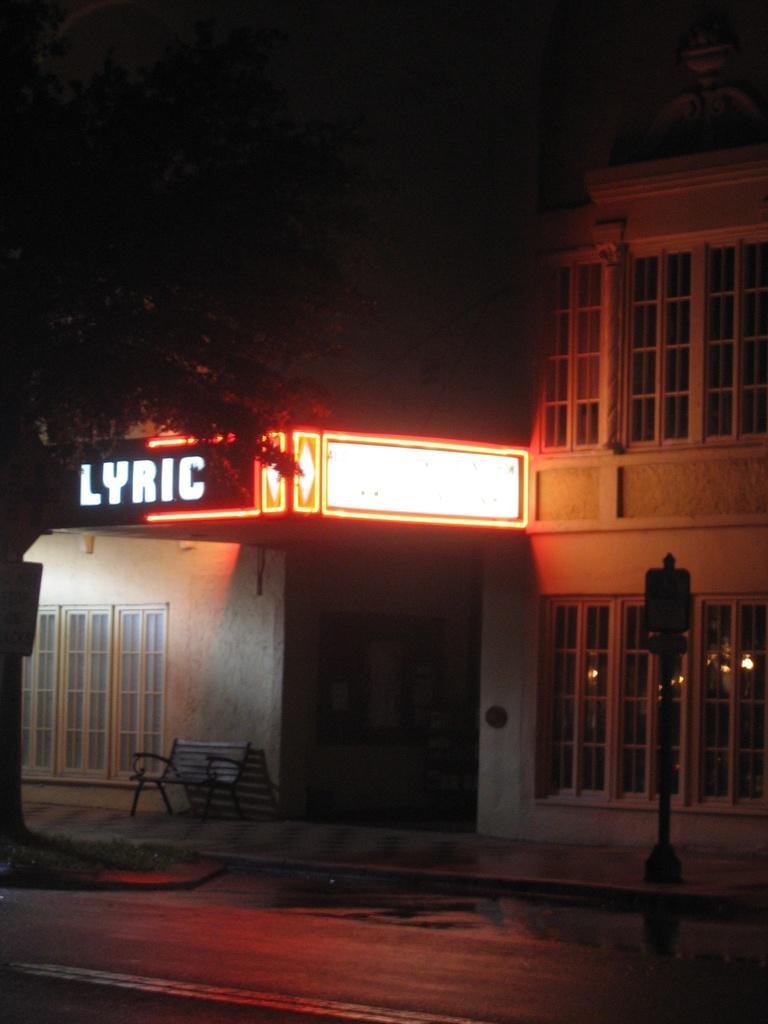Describe this image in one or two sentences. There is a road. In the background, there is a pole, there is a tree, there is a bench, beside this bench, there is a building which is having glass windows and a hoarding and a light on the wall. 